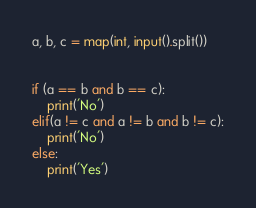<code> <loc_0><loc_0><loc_500><loc_500><_Python_>a, b, c = map(int, input().split()) 


if (a == b and b == c):
    print('No')
elif(a != c and a != b and b != c):
    print('No')
else:
    print('Yes')
</code> 